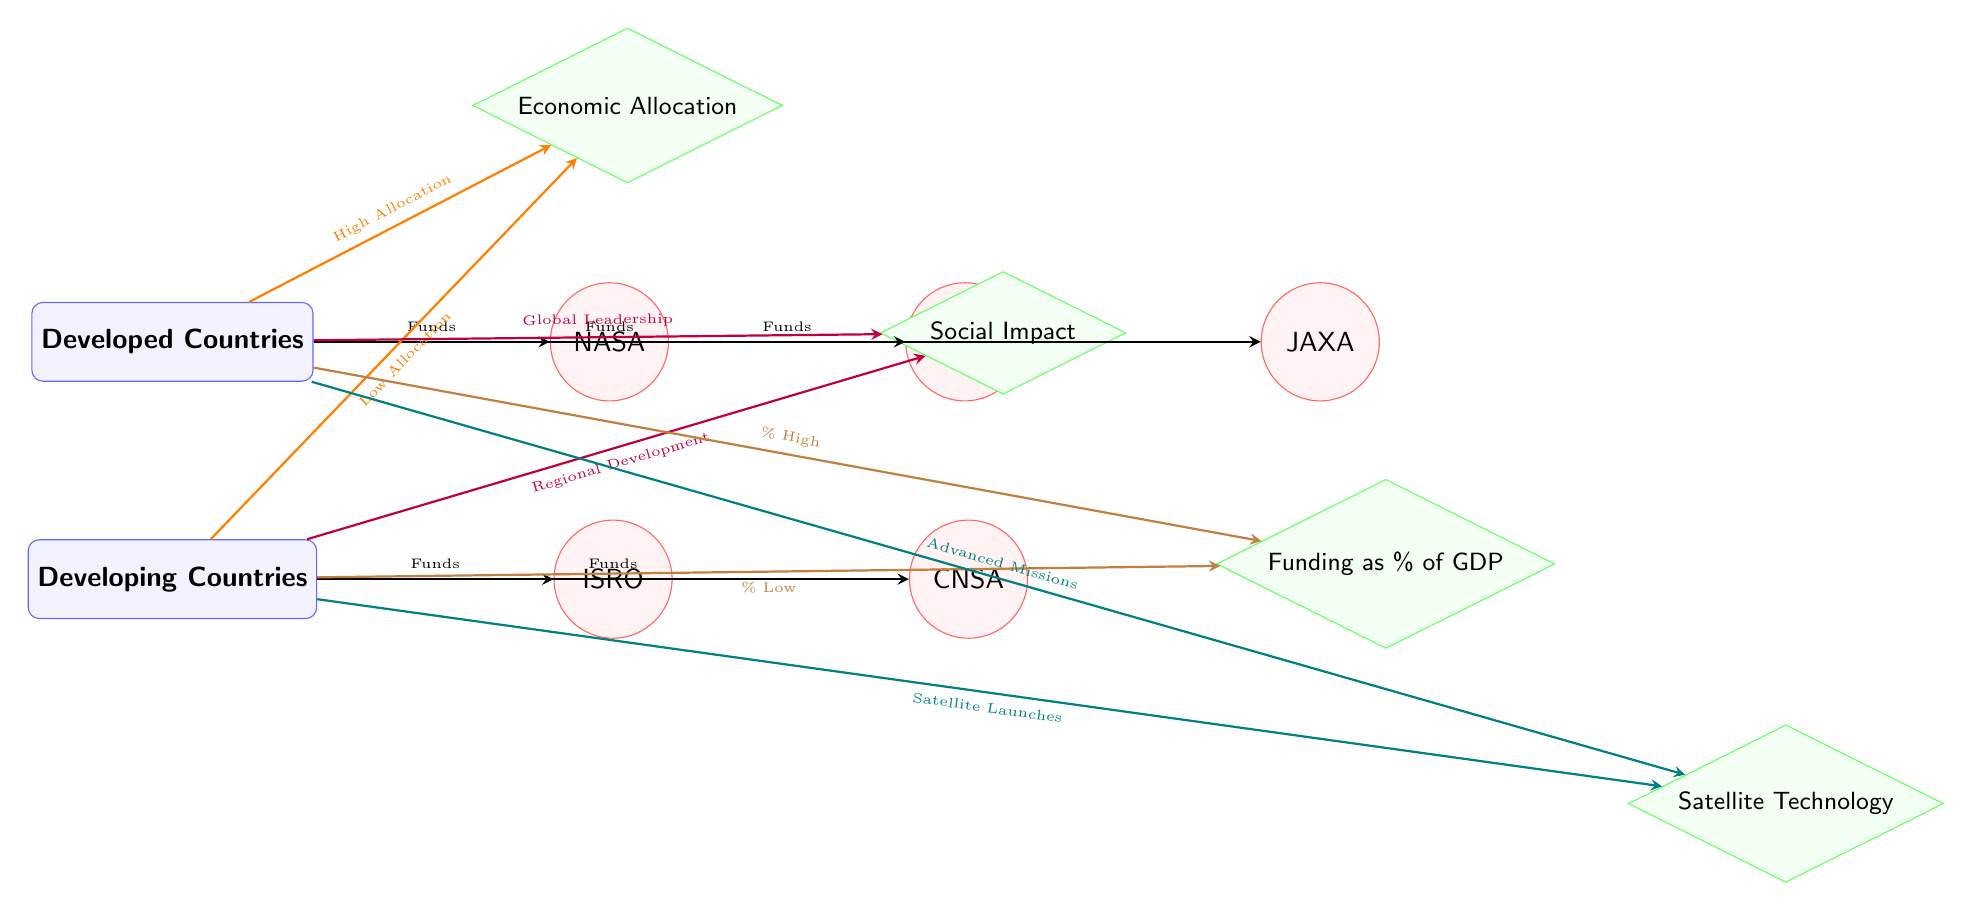What agencies are associated with developed countries? The diagram shows three agencies connected to developed countries: NASA, ESA, and JAXA. These agencies receive funds from the developed countries as indicated by the arrows leading from the "Developed Countries" node to each agency.
Answer: NASA, ESA, JAXA What is the impact of funding as a percentage of GDP in developing countries? The diagram points out that the funding as a percentage of GDP for developing countries is labeled as "Low" compared to the "High" allocation for developed countries. This distinction is visually represented by arrows leading to the "Funding as % of GDP" node from both country types.
Answer: Low How many funding agencies are represented for developing countries? The diagram illustrates two funding agencies for developing countries: ISRO and CNSA, both clearly connected to the "Developing Countries" node by arrows indicating funds. Therefore, the count is determined from the nodes connected to the developing countries.
Answer: 2 What is the main social impact of space exploration funding in developed countries? From the diagram, the social impact of space exploration funding in developed countries emphasizes "Global Leadership." This is indicated by the arrow leading from the "Developed Countries" to the "Social Impact" node labeled with that term.
Answer: Global Leadership What does the term "Advanced Missions" relate to in terms of developed countries? The term "Advanced Missions" is tied to the funding initiatives for developed countries as shown in the diagram. An arrow from the "Developed Countries" node directly points to the "Satellite Technology" node, labeled with this term, indicating that developed countries focus on advanced missions within the satellite sector.
Answer: Advanced Missions What type of allocations does funding in developed countries represent? The diagram categorizes the allocations in developed countries as "High Allocation," illustrated by the arrow from the "Developed Countries" node leading to the "Economic Allocation" node. This nodes express the higher level of funding compared to the economic allocations from developing countries.
Answer: High Allocation How does the satellite technology funding differ between developed and developing countries? The satellite technology funding in developed countries is associated with "Advanced Missions," whereas developing countries show a different focus as indicated by the label "Satellite Launches." This differentiation is made clear through the arrows pointing to the same "Satellite Technology" node from each country type, showcasing their distinct priorities.
Answer: Advanced Missions vs. Satellite Launches What does the diagram indicate about the priorities of space funding agencies in developing countries? The diagram highlights that the priorities of space funding agencies in developing countries, represented by ISRO and CNSA, lean towards "Regional Development." This is indicated by the arrow leading from the "Developing Countries" node to the "Social Impact" node distinctly labeled as such.
Answer: Regional Development 